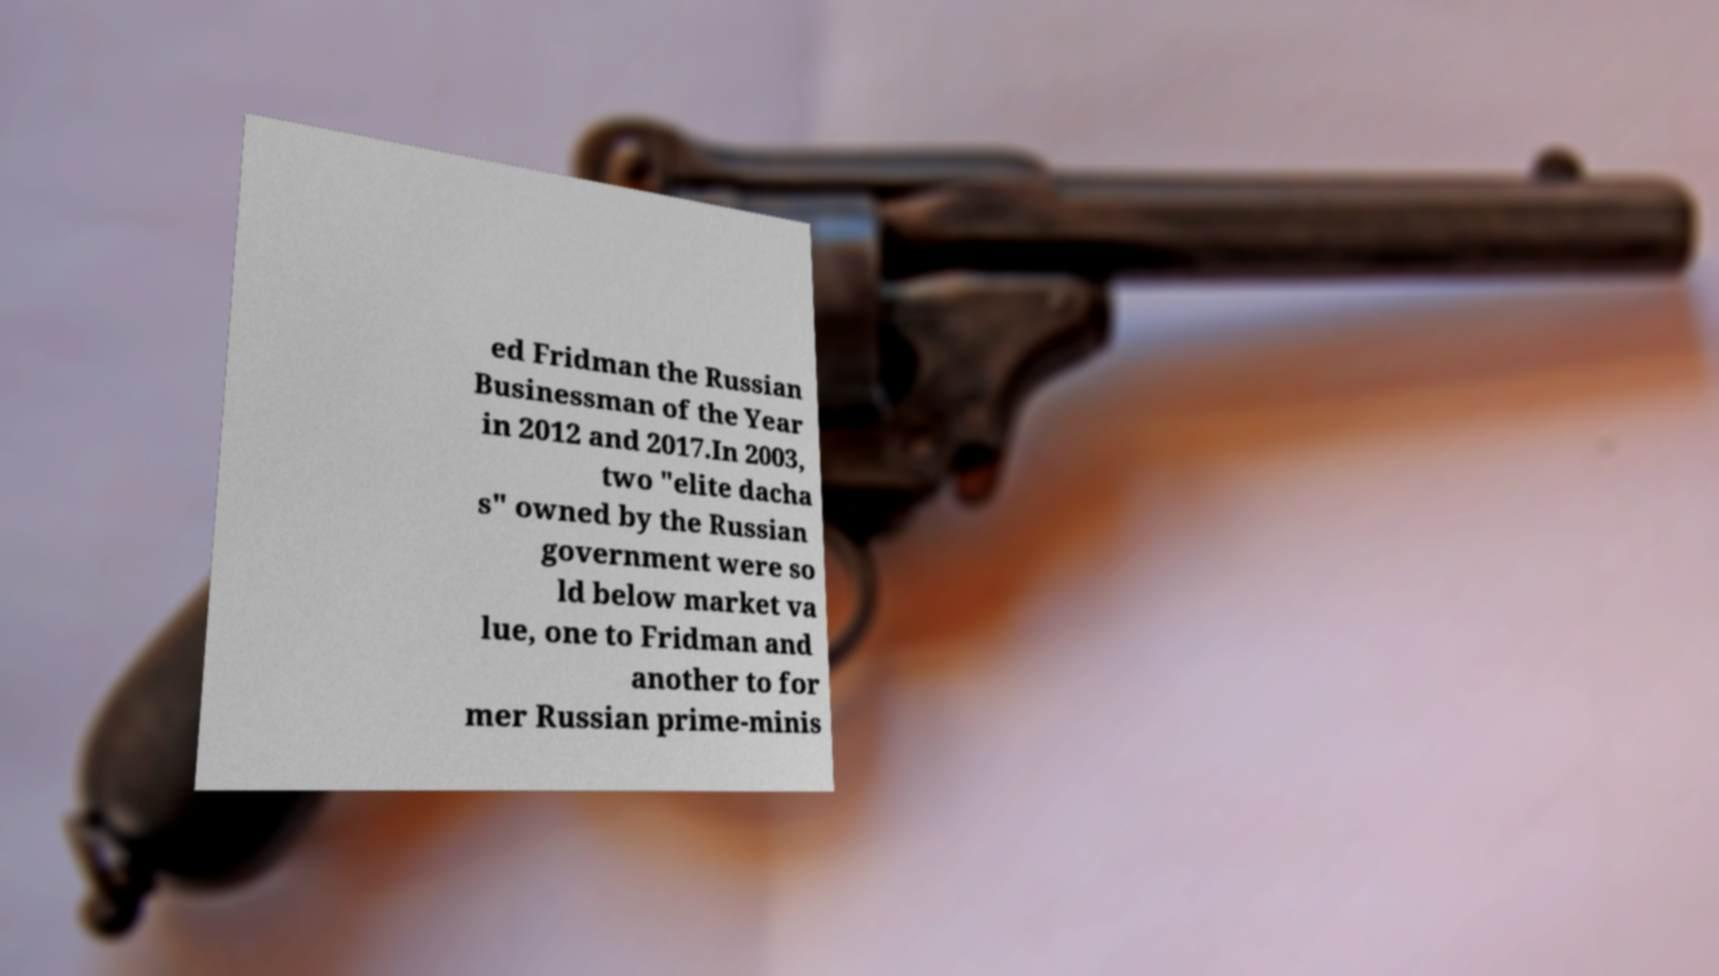Please read and relay the text visible in this image. What does it say? ed Fridman the Russian Businessman of the Year in 2012 and 2017.In 2003, two "elite dacha s" owned by the Russian government were so ld below market va lue, one to Fridman and another to for mer Russian prime-minis 